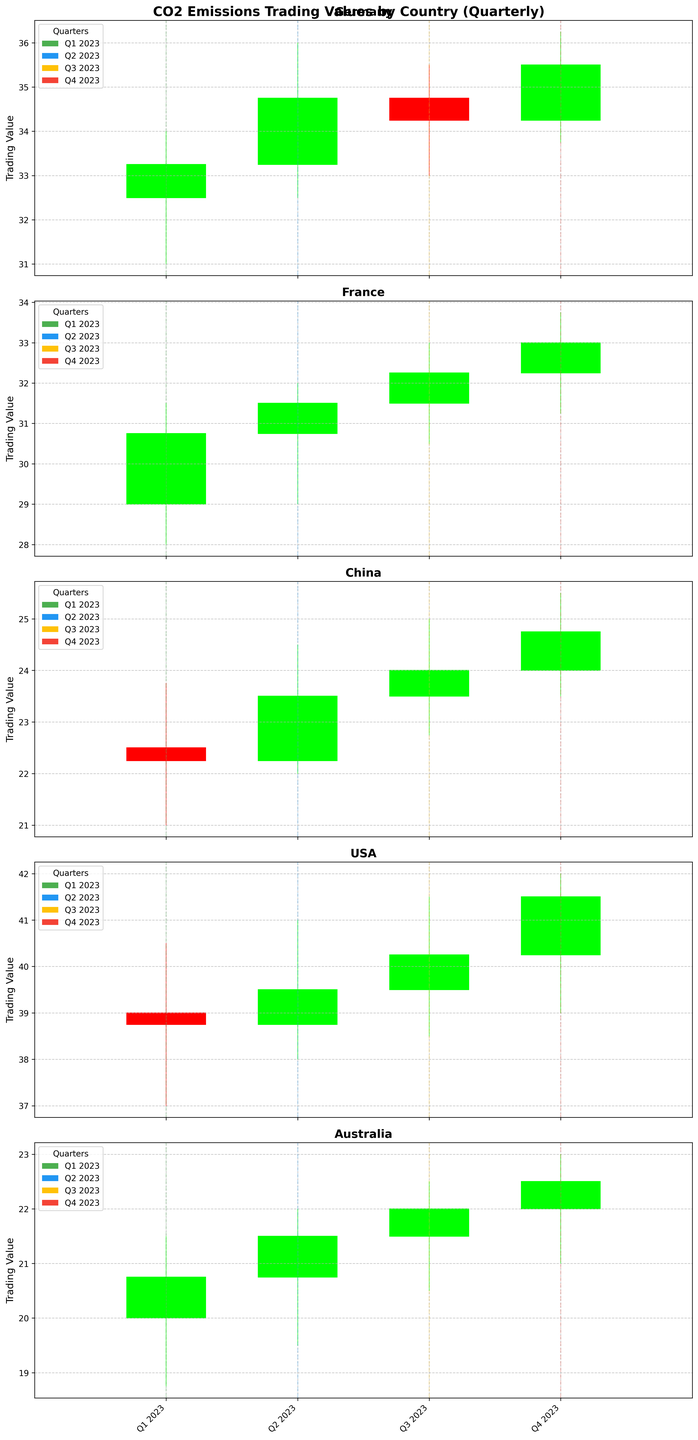Which country has the highest closing value in Q4 2023? By observing the closing values for Q4 2023 in each subplot, we notice that the USA has the highest closing value with 41.50.
Answer: USA What's the range of trading values for China in Q3 2023? The range is the difference between the highest and the lowest trading value. For China in Q3 2023, the high is 25.00 and the low is 22.75, so the range is 25.00 - 22.75 = 2.25.
Answer: 2.25 Compare the closing values of Germany in Q1 2023 and Q2 2023. Which one is higher? The closing value for Germany in Q1 2023 is 33.25 and in Q2 2023 is 34.75. By comparing, we see that Q2 2023 is higher.
Answer: Q2 2023 In which quarter does France have its peak trading value in 2023? To find the quarter with the peak trading value for France, we compare the high values for each quarter. France reaches its peak in Q4 2023 with a high value of 33.75.
Answer: Q4 2023 How does the trading value for Australia change from Q1 2023 to Q4 2023? We can track the opening and closing values for Australia from Q1 to Q4. The values increase each quarter, starting at a close of 20.75 in Q1 and reaching 22.50 in Q4. This shows a steady upward trend.
Answer: Increases Which country shows the least volatility in Q2 2023? Volatility can be inferred from the difference between the high and low values. Comparing the high-low differences in Q2 2023, Australia (22.00 - 19.50 = 2.50) shows the least volatility.
Answer: Australia Calculate the average closing value for Germany throughout 2023. The closing values for Germany are 33.25 (Q1), 34.75 (Q2), 34.25 (Q3), and 35.50 (Q4). The average is calculated as (33.25 + 34.75 + 34.25 + 35.50) / 4 = 34.44.
Answer: 34.44 Which country has the highest closing value on average in 2023? We need to calculate the average closing value for each country and compare. After calculating, we see the USA has the highest average closing value.
Answer: USA Is there any country that consistently shows an upward trend in closing values each quarter? Reviewing the closing values for each country from Q1 to Q4, Australia shows a consistent upward trend with values 20.75, 21.50, 22.00, and 22.50.
Answer: Australia During which quarters do the trading values span the widest range (most volatility) for Germany? For Germany, we compare the high-low ranges: Q1 (34.00-31.00=3.00), Q2 (36.00-32.50=3.50), Q3 (35.50-33.00=2.50), Q4 (36.25-33.75=2.50). The widest range is in Q2 2023 with 3.50.
Answer: Q2 2023 